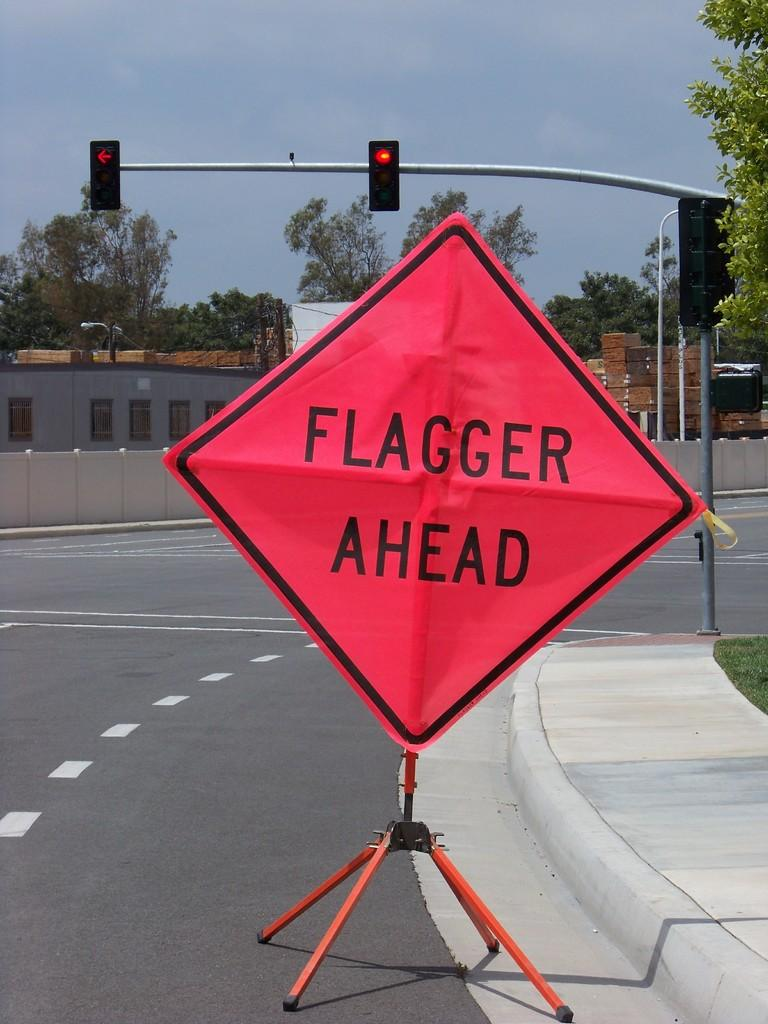<image>
Relay a brief, clear account of the picture shown. A red sign saying Flagger Ahead on a street with a traffic light in the background. 